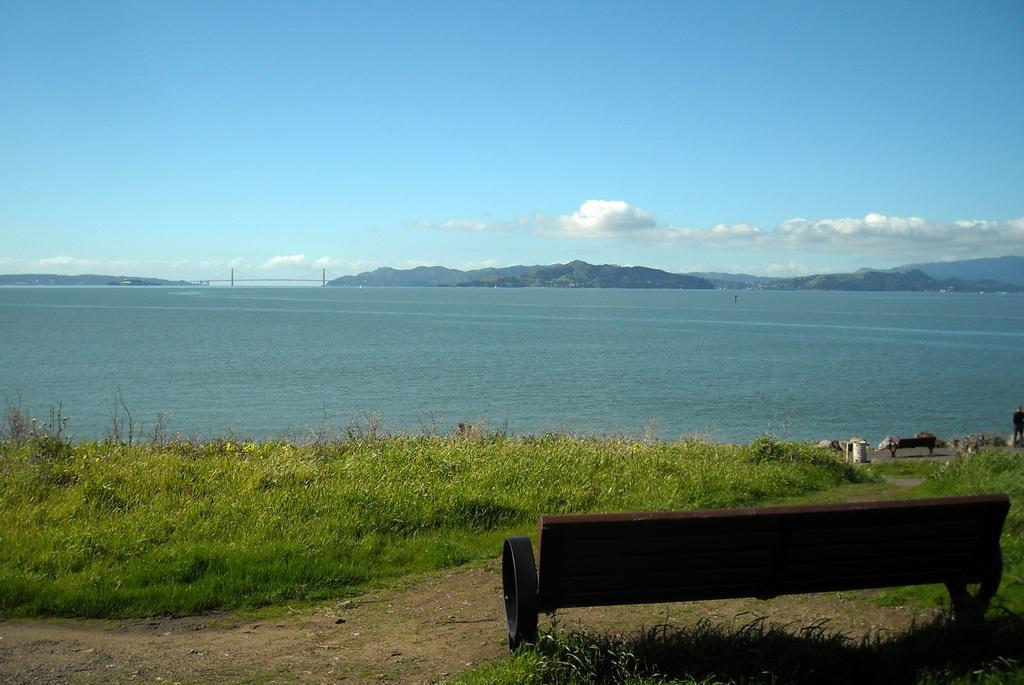Could you give a brief overview of what you see in this image? In this image, we can see the water, grass, plants, benches, few objects and walkway. Background there are so many hills and sky. Here it looks like a bridge. 